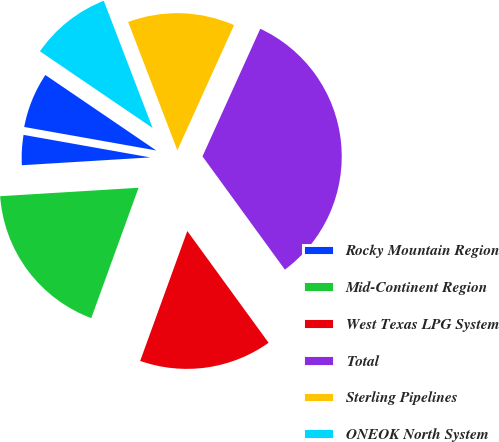Convert chart. <chart><loc_0><loc_0><loc_500><loc_500><pie_chart><fcel>Rocky Mountain Region<fcel>Mid-Continent Region<fcel>West Texas LPG System<fcel>Total<fcel>Sterling Pipelines<fcel>ONEOK North System<fcel>Other<nl><fcel>3.77%<fcel>18.49%<fcel>15.55%<fcel>33.22%<fcel>12.6%<fcel>9.66%<fcel>6.71%<nl></chart> 